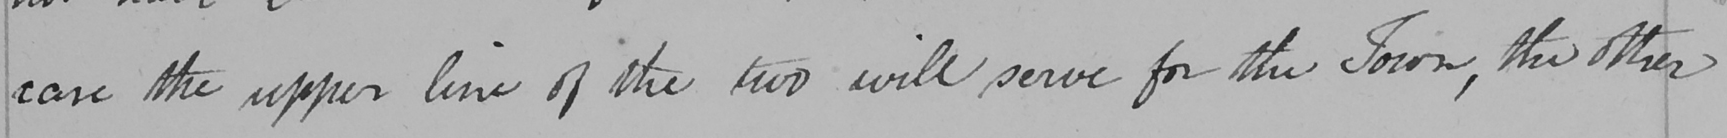What text is written in this handwritten line? case the upper line of the two will serve for the Town , the other 